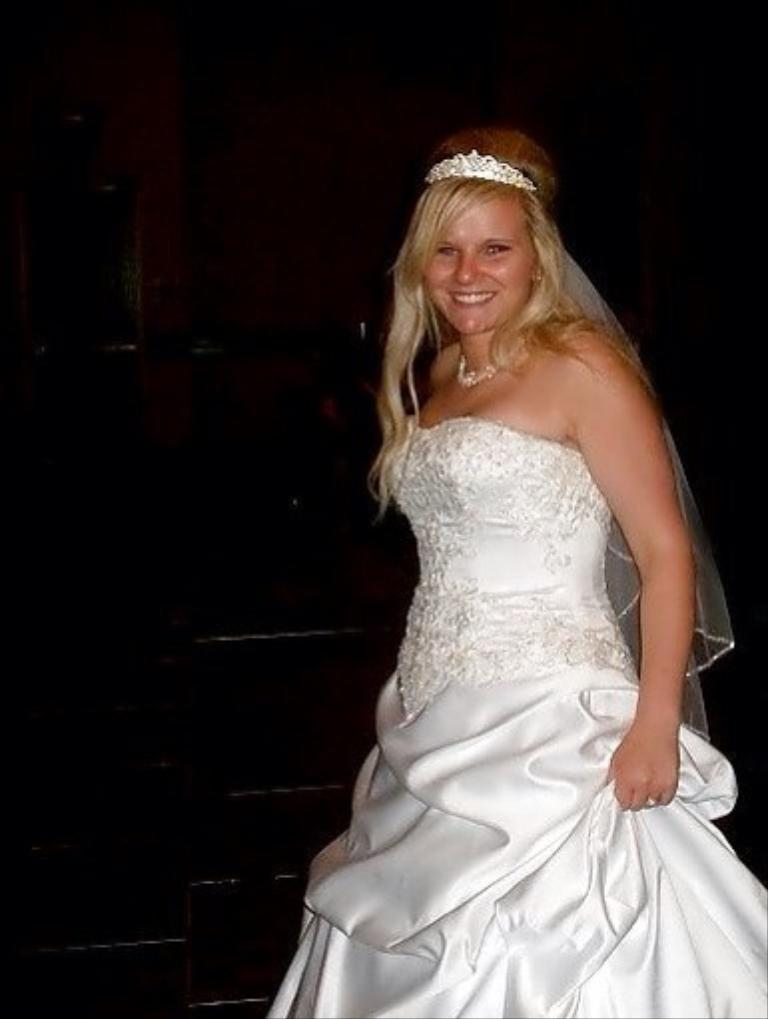What is the woman in the image wearing? The woman is wearing a white frock. What accessory is the woman wearing on her head? The woman is wearing a crown. What expression does the woman have in the image? The woman is smiling. What can be seen in the background of the image? The background of the image is dark. What type of haircut does the judge have in the image? There is no judge present in the image, and therefore no haircut to describe. 